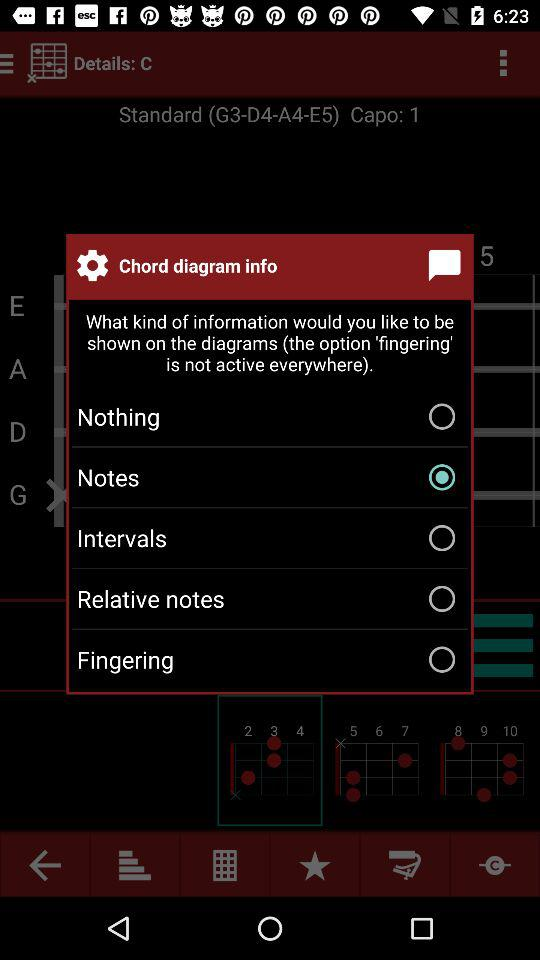How many options are available for the chord diagram info?
Answer the question using a single word or phrase. 5 